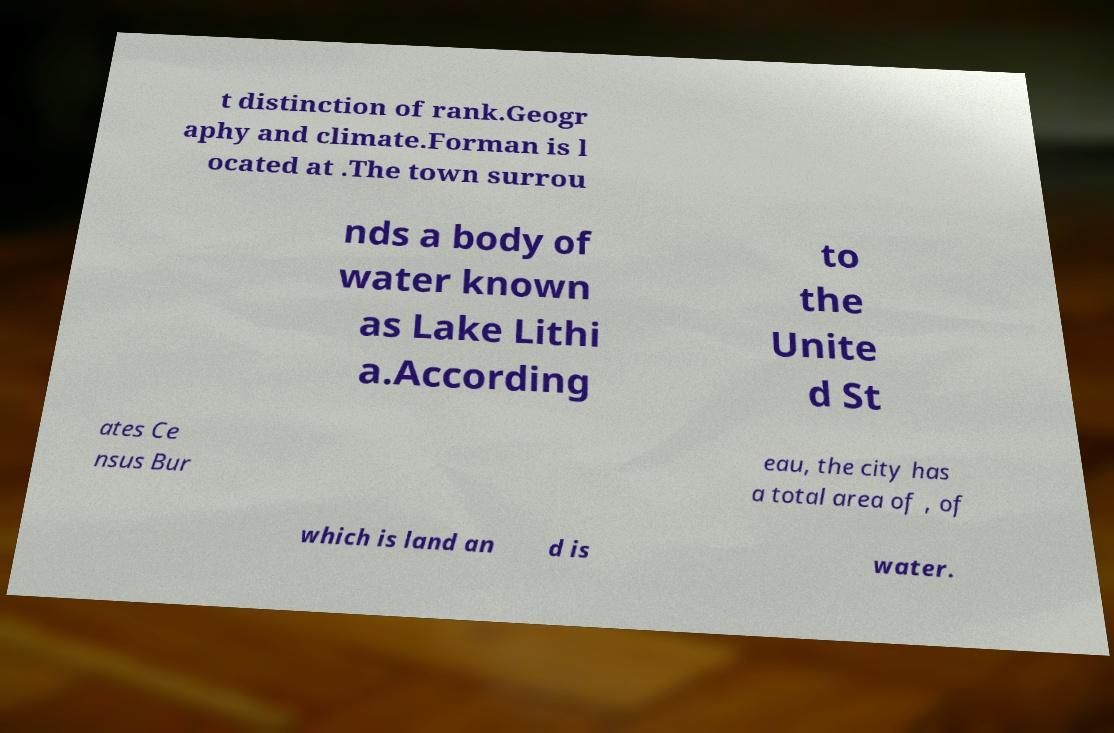Could you extract and type out the text from this image? t distinction of rank.Geogr aphy and climate.Forman is l ocated at .The town surrou nds a body of water known as Lake Lithi a.According to the Unite d St ates Ce nsus Bur eau, the city has a total area of , of which is land an d is water. 